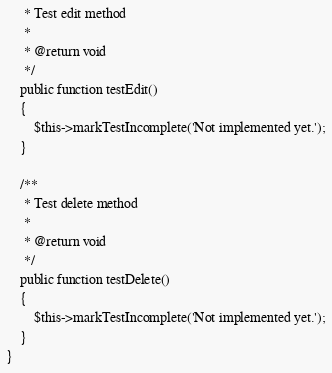<code> <loc_0><loc_0><loc_500><loc_500><_PHP_>     * Test edit method
     *
     * @return void
     */
    public function testEdit()
    {
        $this->markTestIncomplete('Not implemented yet.');
    }

    /**
     * Test delete method
     *
     * @return void
     */
    public function testDelete()
    {
        $this->markTestIncomplete('Not implemented yet.');
    }
}
</code> 